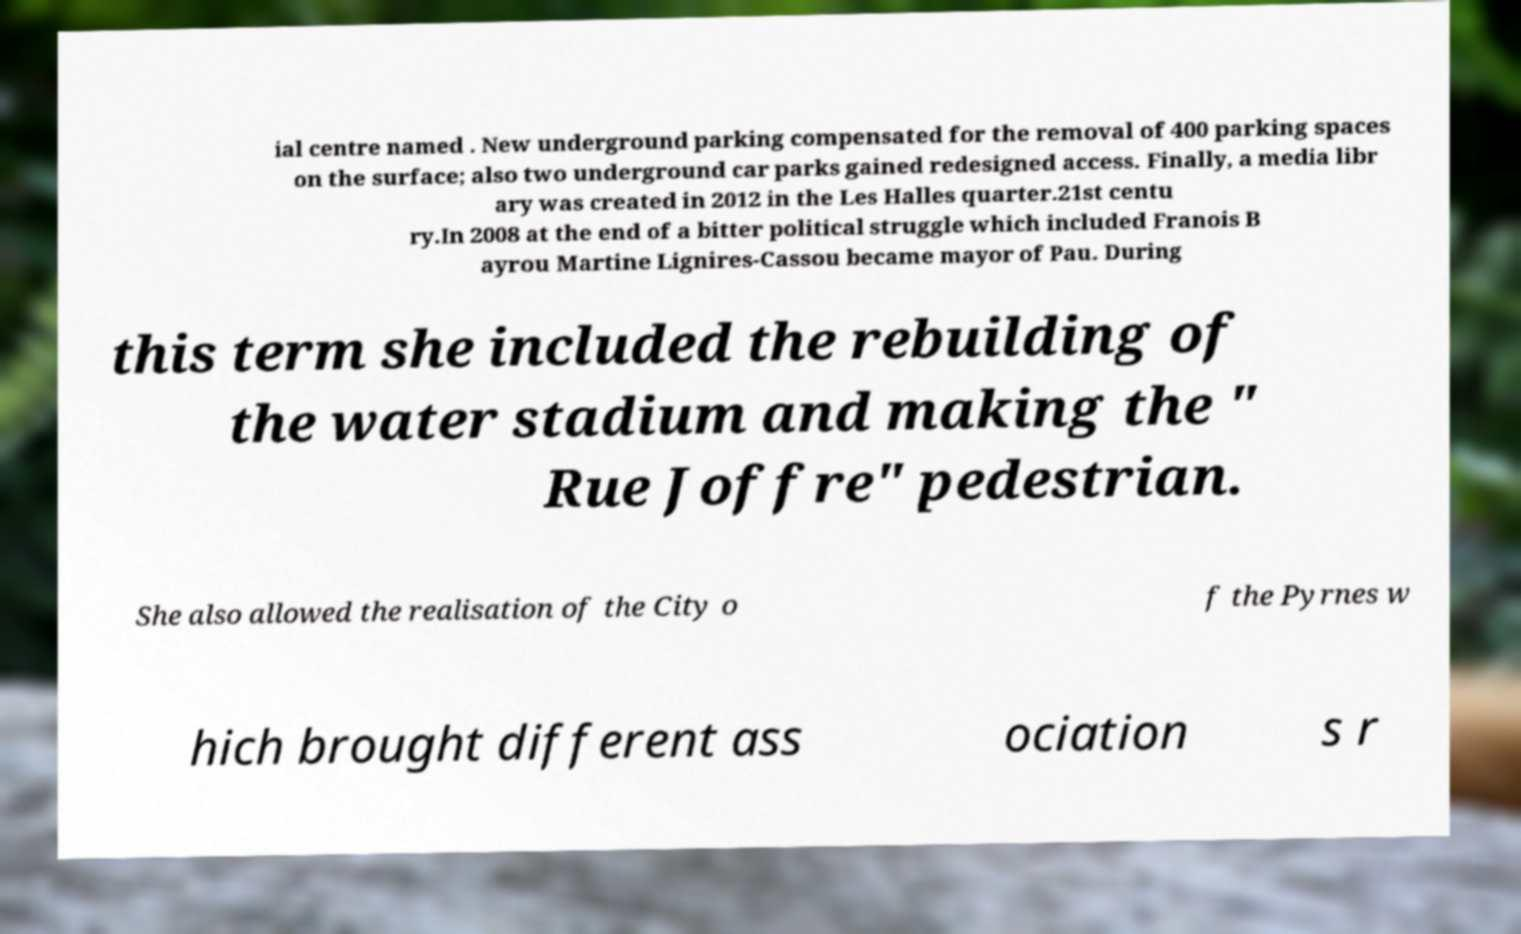Could you extract and type out the text from this image? ial centre named . New underground parking compensated for the removal of 400 parking spaces on the surface; also two underground car parks gained redesigned access. Finally, a media libr ary was created in 2012 in the Les Halles quarter.21st centu ry.In 2008 at the end of a bitter political struggle which included Franois B ayrou Martine Lignires-Cassou became mayor of Pau. During this term she included the rebuilding of the water stadium and making the " Rue Joffre" pedestrian. She also allowed the realisation of the City o f the Pyrnes w hich brought different ass ociation s r 